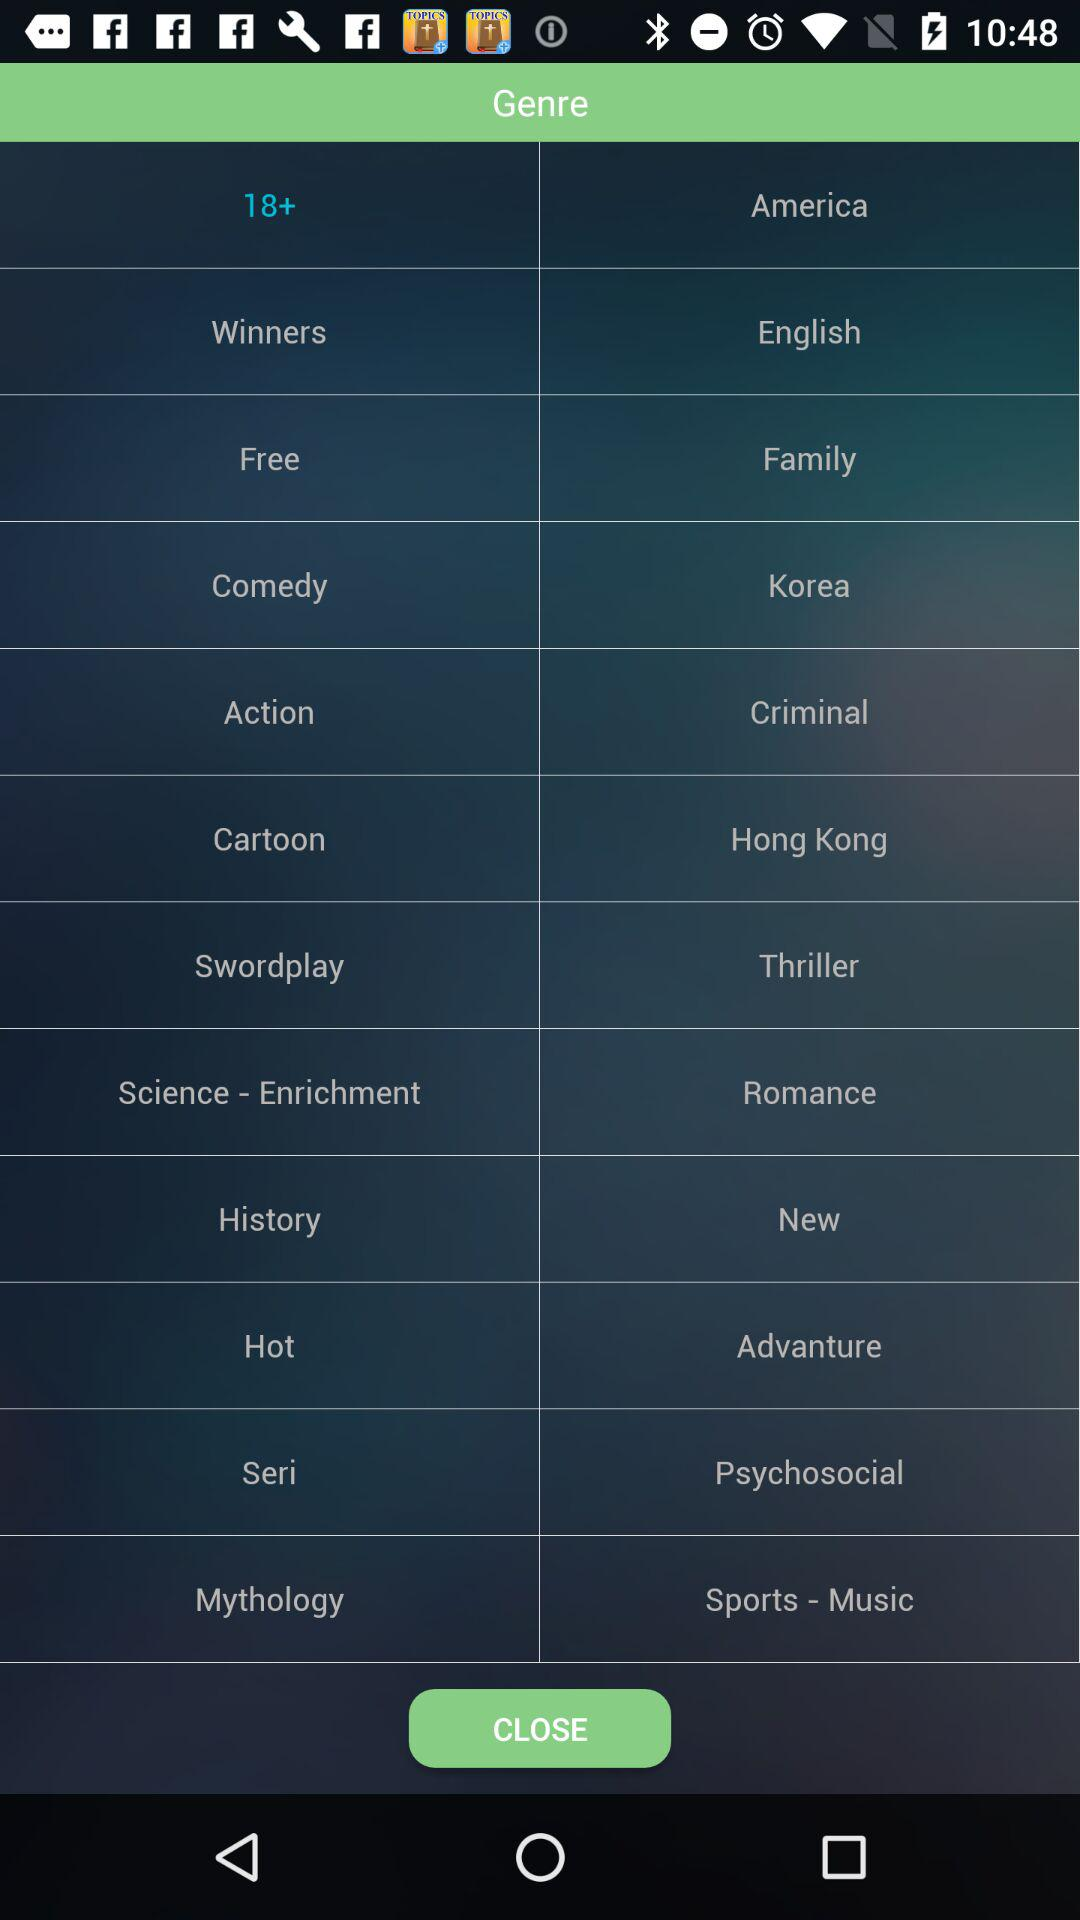Which genre option is selected? The selected genre option is "18+". 